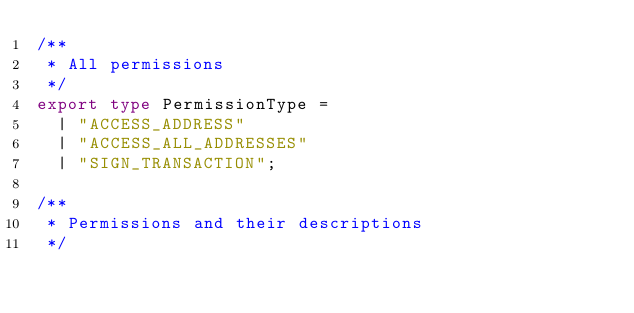<code> <loc_0><loc_0><loc_500><loc_500><_TypeScript_>/**
 * All permissions
 */
export type PermissionType =
  | "ACCESS_ADDRESS"
  | "ACCESS_ALL_ADDRESSES"
  | "SIGN_TRANSACTION";

/**
 * Permissions and their descriptions
 */</code> 